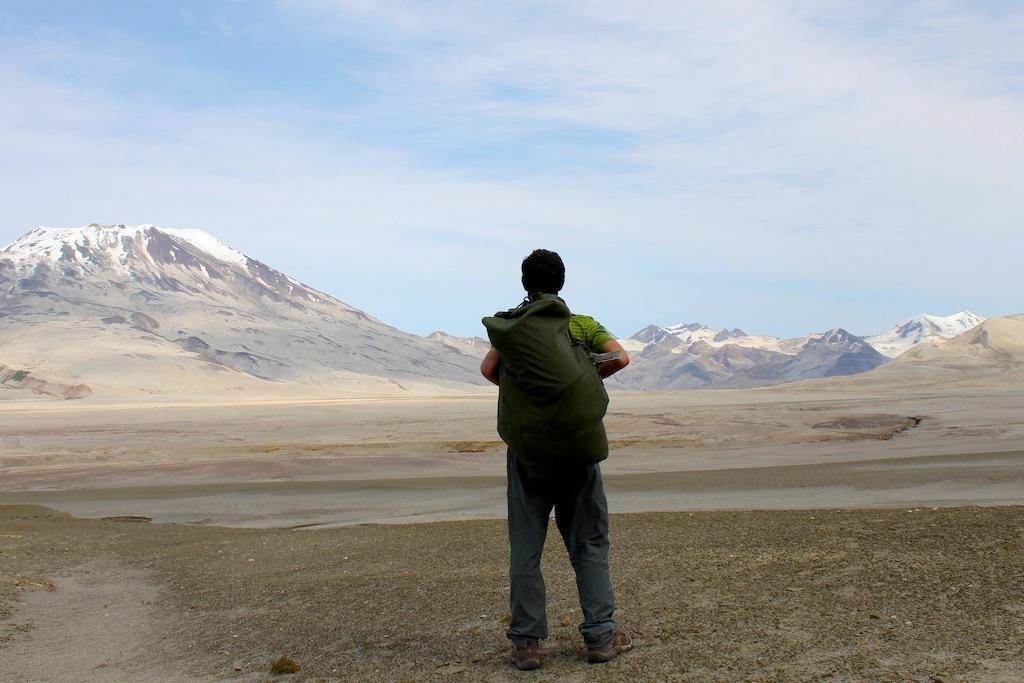In one or two sentences, can you explain what this image depicts? In this image there is one person standing and holding a bag in the middle of this image. There are some mountains in the background. There is a ground in the bottom of this image and there is a sky on the top of this image. 